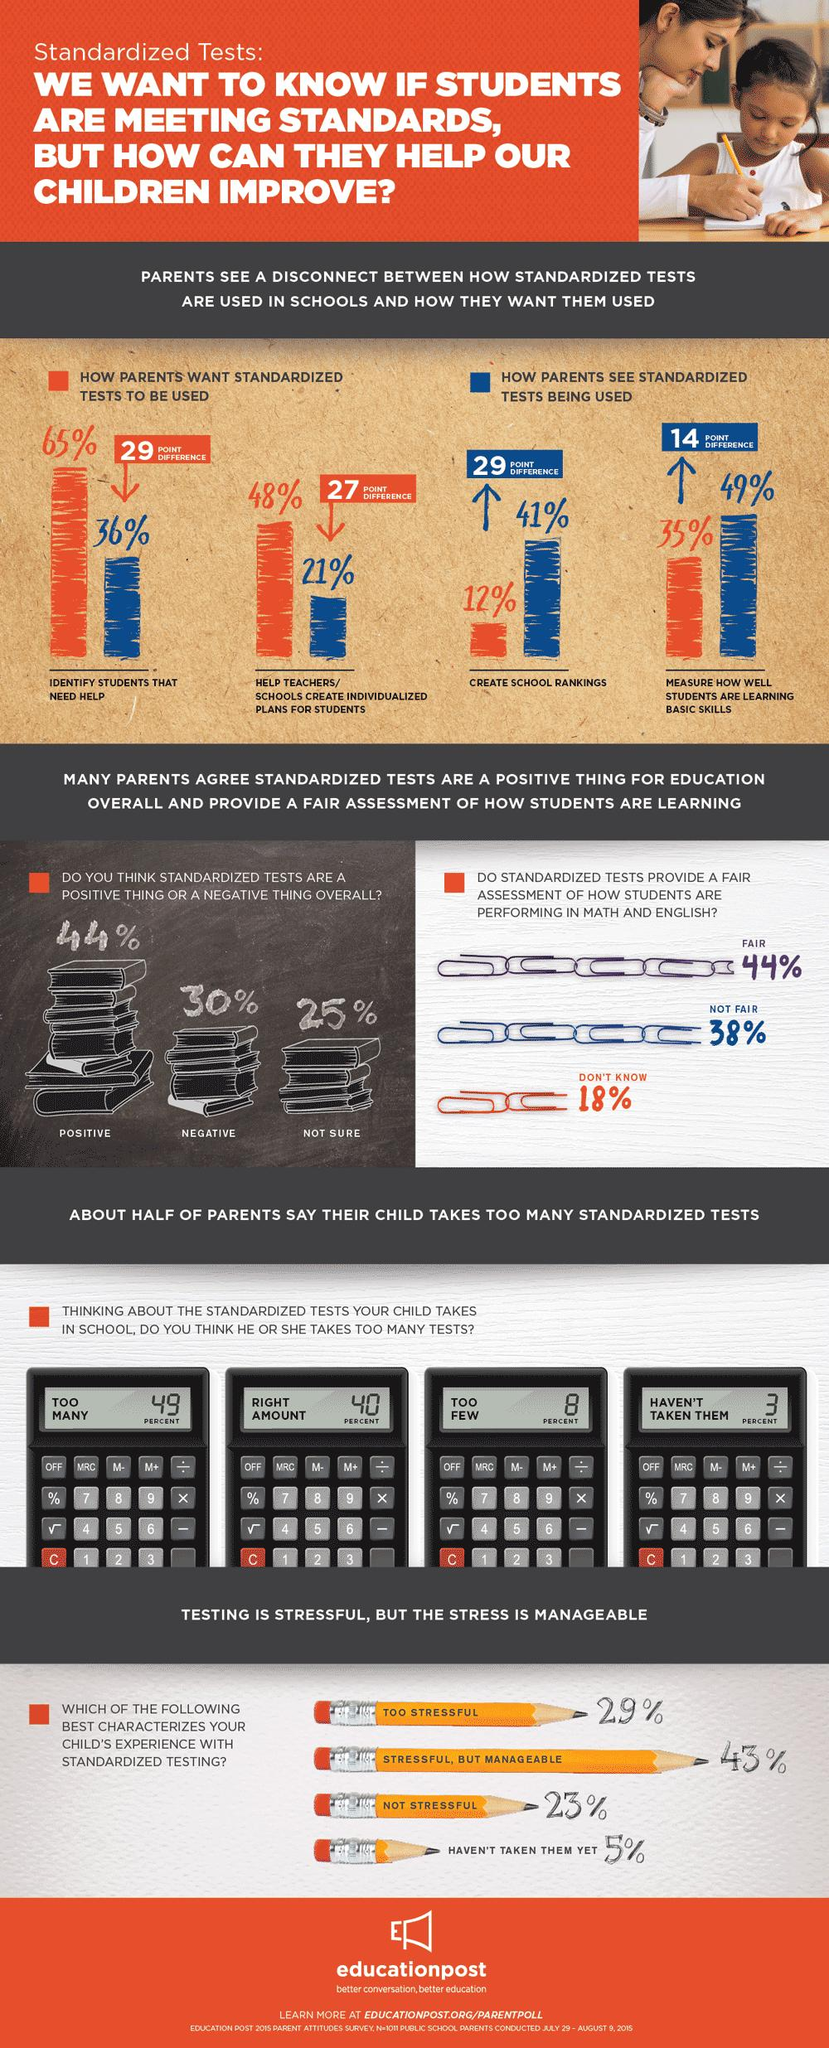Mention a couple of crucial points in this snapshot. According to a recent survey, only 12% of parents support the use of standardized tests to create school rankings. According to a survey conducted among parents, 49% believe that standardized tests are an accurate measurement of how well students are learning. According to the parents surveyed, 8% believe that not enough tests are administered. Si se desea utilizar pruebas para identificar estudiantes que necesitan ayuda, lo desean el 65% de los padres. According to a survey of parents, 49% believe that the number of tests their children are taking is too many. 